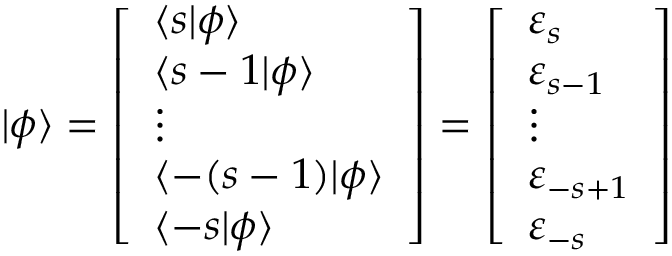Convert formula to latex. <formula><loc_0><loc_0><loc_500><loc_500>| \phi \rangle = { \left [ \begin{array} { l } { \langle s | \phi \rangle } \\ { \langle s - 1 | \phi \rangle } \\ { \vdots } \\ { \langle - ( s - 1 ) | \phi \rangle } \\ { \langle - s | \phi \rangle } \end{array} \right ] } = { \left [ \begin{array} { l } { \varepsilon _ { s } } \\ { \varepsilon _ { s - 1 } } \\ { \vdots } \\ { \varepsilon _ { - s + 1 } } \\ { \varepsilon _ { - s } } \end{array} \right ] }</formula> 